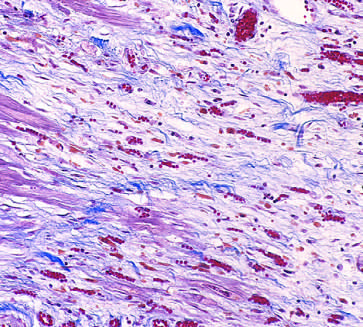s granulation tissue characterized by loose connective tissue and abundant capillaries?
Answer the question using a single word or phrase. Yes 